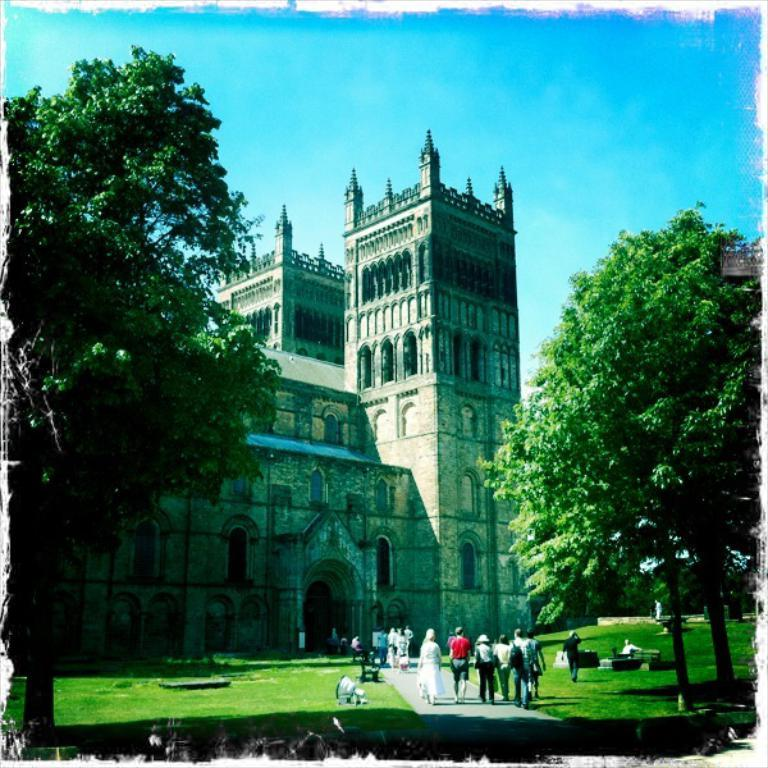What type of structure is present in the image? There is a building in the image. Who or what can be seen in the image besides the building? There are people visible in the image. What type of natural environment is present in the image? There is grass and trees visible in the image. What can be seen in the background of the image? The sky is visible in the background of the image. Where is the oven located in the image? There is no oven present in the image. How many men are visible in the image? The provided facts do not specify the gender of the people in the image, so it is impossible to determine the number of men. 